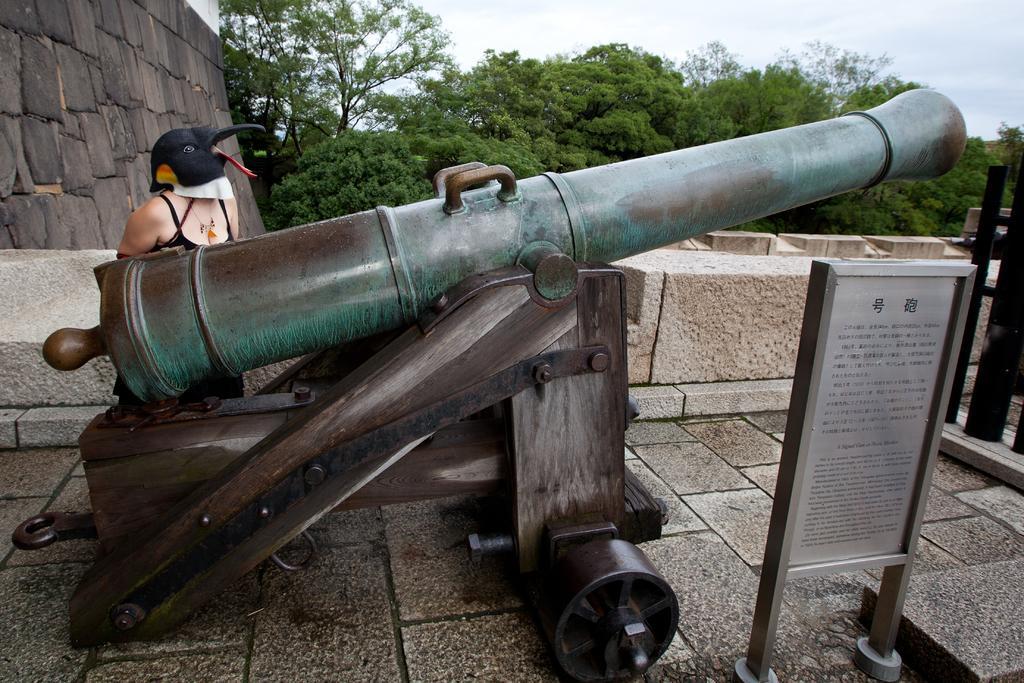Describe this image in one or two sentences. In the picture I can see a person is standing and wearing mask on the head. I can also see a canon, fence and a board which has something written on it. In the background I can see trees, wall and the sky. 